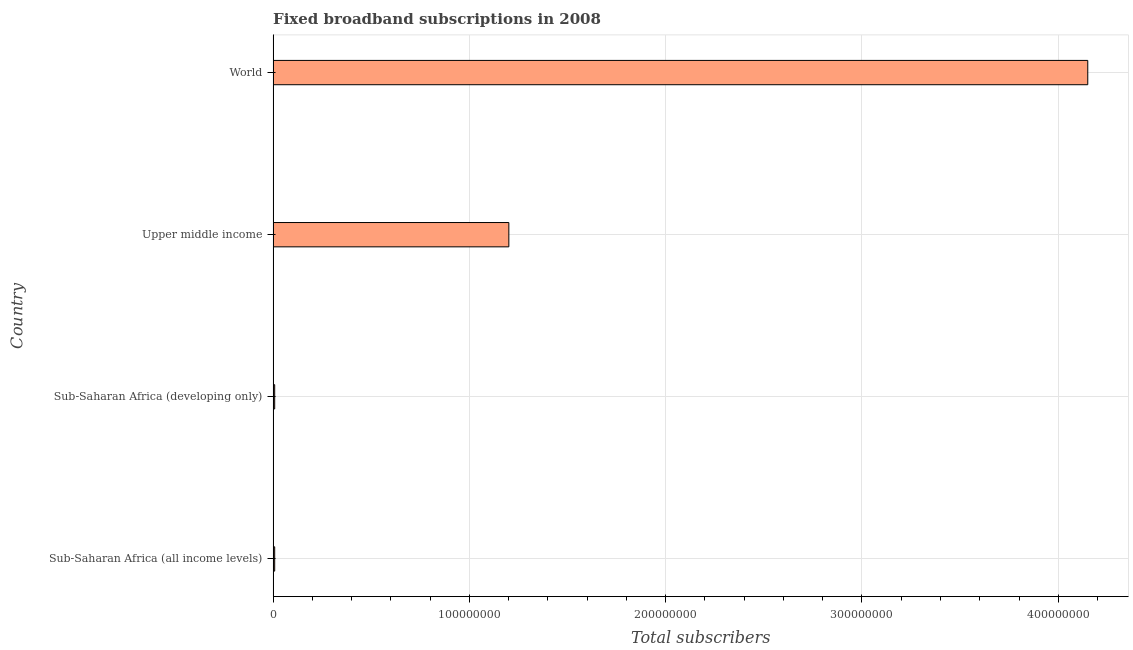Does the graph contain grids?
Offer a very short reply. Yes. What is the title of the graph?
Your response must be concise. Fixed broadband subscriptions in 2008. What is the label or title of the X-axis?
Offer a terse response. Total subscribers. What is the total number of fixed broadband subscriptions in Upper middle income?
Provide a short and direct response. 1.20e+08. Across all countries, what is the maximum total number of fixed broadband subscriptions?
Give a very brief answer. 4.15e+08. Across all countries, what is the minimum total number of fixed broadband subscriptions?
Keep it short and to the point. 7.97e+05. In which country was the total number of fixed broadband subscriptions maximum?
Offer a terse response. World. In which country was the total number of fixed broadband subscriptions minimum?
Your answer should be compact. Sub-Saharan Africa (developing only). What is the sum of the total number of fixed broadband subscriptions?
Offer a very short reply. 5.37e+08. What is the difference between the total number of fixed broadband subscriptions in Sub-Saharan Africa (developing only) and Upper middle income?
Offer a very short reply. -1.19e+08. What is the average total number of fixed broadband subscriptions per country?
Your response must be concise. 1.34e+08. What is the median total number of fixed broadband subscriptions?
Offer a very short reply. 6.04e+07. What is the ratio of the total number of fixed broadband subscriptions in Sub-Saharan Africa (all income levels) to that in Upper middle income?
Your answer should be very brief. 0.01. Is the total number of fixed broadband subscriptions in Sub-Saharan Africa (developing only) less than that in World?
Make the answer very short. Yes. Is the difference between the total number of fixed broadband subscriptions in Sub-Saharan Africa (all income levels) and Sub-Saharan Africa (developing only) greater than the difference between any two countries?
Offer a terse response. No. What is the difference between the highest and the second highest total number of fixed broadband subscriptions?
Your answer should be compact. 2.95e+08. Is the sum of the total number of fixed broadband subscriptions in Sub-Saharan Africa (all income levels) and Upper middle income greater than the maximum total number of fixed broadband subscriptions across all countries?
Your answer should be compact. No. What is the difference between the highest and the lowest total number of fixed broadband subscriptions?
Keep it short and to the point. 4.14e+08. In how many countries, is the total number of fixed broadband subscriptions greater than the average total number of fixed broadband subscriptions taken over all countries?
Offer a very short reply. 1. Are all the bars in the graph horizontal?
Keep it short and to the point. Yes. How many countries are there in the graph?
Your answer should be very brief. 4. Are the values on the major ticks of X-axis written in scientific E-notation?
Provide a short and direct response. No. What is the Total subscribers of Sub-Saharan Africa (all income levels)?
Offer a terse response. 8.00e+05. What is the Total subscribers in Sub-Saharan Africa (developing only)?
Offer a very short reply. 7.97e+05. What is the Total subscribers of Upper middle income?
Your answer should be very brief. 1.20e+08. What is the Total subscribers in World?
Give a very brief answer. 4.15e+08. What is the difference between the Total subscribers in Sub-Saharan Africa (all income levels) and Sub-Saharan Africa (developing only)?
Provide a short and direct response. 3597. What is the difference between the Total subscribers in Sub-Saharan Africa (all income levels) and Upper middle income?
Your answer should be very brief. -1.19e+08. What is the difference between the Total subscribers in Sub-Saharan Africa (all income levels) and World?
Give a very brief answer. -4.14e+08. What is the difference between the Total subscribers in Sub-Saharan Africa (developing only) and Upper middle income?
Your response must be concise. -1.19e+08. What is the difference between the Total subscribers in Sub-Saharan Africa (developing only) and World?
Provide a succinct answer. -4.14e+08. What is the difference between the Total subscribers in Upper middle income and World?
Ensure brevity in your answer.  -2.95e+08. What is the ratio of the Total subscribers in Sub-Saharan Africa (all income levels) to that in Upper middle income?
Offer a terse response. 0.01. What is the ratio of the Total subscribers in Sub-Saharan Africa (all income levels) to that in World?
Keep it short and to the point. 0. What is the ratio of the Total subscribers in Sub-Saharan Africa (developing only) to that in Upper middle income?
Your response must be concise. 0.01. What is the ratio of the Total subscribers in Sub-Saharan Africa (developing only) to that in World?
Ensure brevity in your answer.  0. What is the ratio of the Total subscribers in Upper middle income to that in World?
Your answer should be compact. 0.29. 